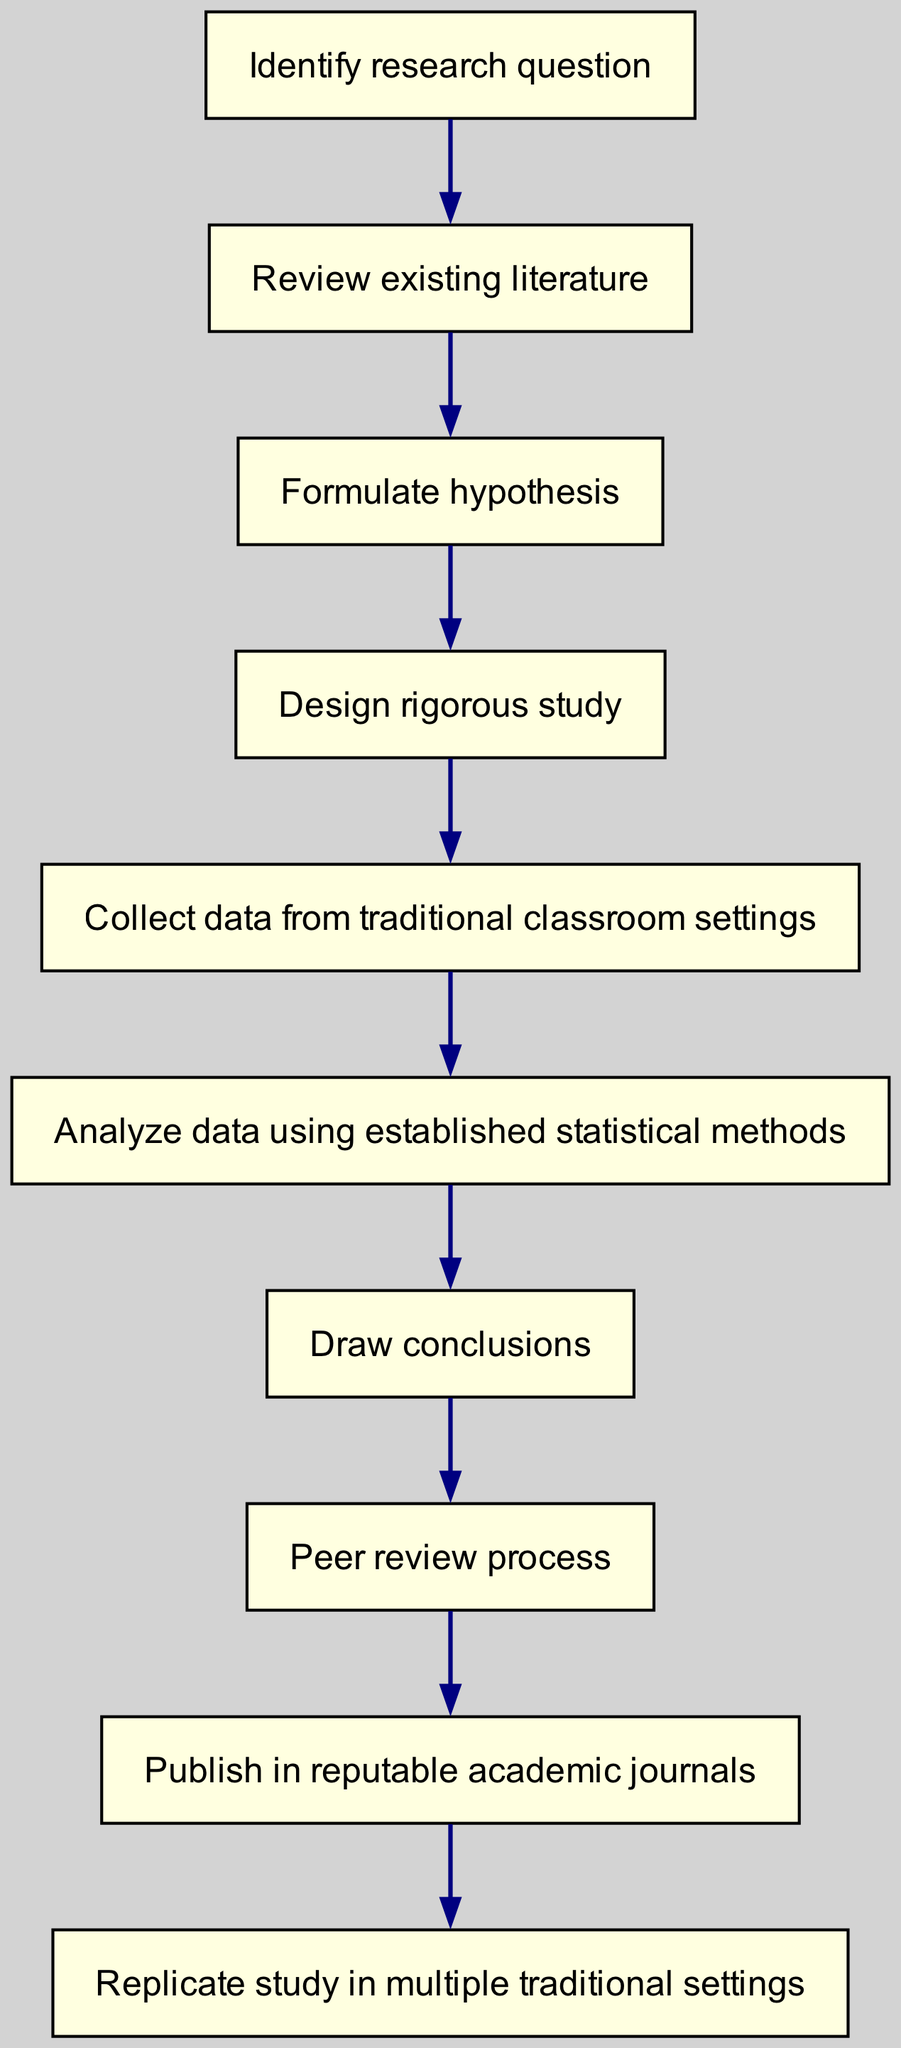What is the first step in the scientific method for educational research? The first step is to identify the research question, as indicated by the first node in the diagram.
Answer: Identify research question How many total steps are there in the flow chart? Counting all the steps from the identification of the research question to the replication of the study, there are ten steps in total.
Answer: Ten Which step follows the data analysis? After analyzing data using established statistical methods, the next step is to draw conclusions, as shown in the flow of the diagram.
Answer: Draw conclusions What is the last step of the scientific method in this flow chart? The final step is to replicate the study in multiple traditional settings, which is the last node in the flow chart.
Answer: Replicate study in multiple traditional settings Explain the relationship between analyzing data and publishing in academic journals? After analyzing data using established statistical methods, the subsequent step is to engage in the peer review process before publishing in reputable academic journals. This illustrates a direct pathway from data analysis to publication.
Answer: Peer review process What type of study does the flow chart emphasize on data collection? The flow chart emphasizes collecting data from traditional classroom settings, which is specified as the fifth step in the chain of research activities.
Answer: Traditional classroom settings Which step is directly before the peer review process? The step that directly precedes the peer review process is drawing conclusions, indicating that conclusions must be reached prior to peer review.
Answer: Draw conclusions Is the hypothesis formulated before or after reviewing existing literature? The hypothesis is formulated after reviewing existing literature, marking a logical flow within the research process shown in the diagram.
Answer: After What critical step is included before publishing the research? The critical step included before publishing the research is the peer review process, which ensures that the research meets academic standards.
Answer: Peer review process 